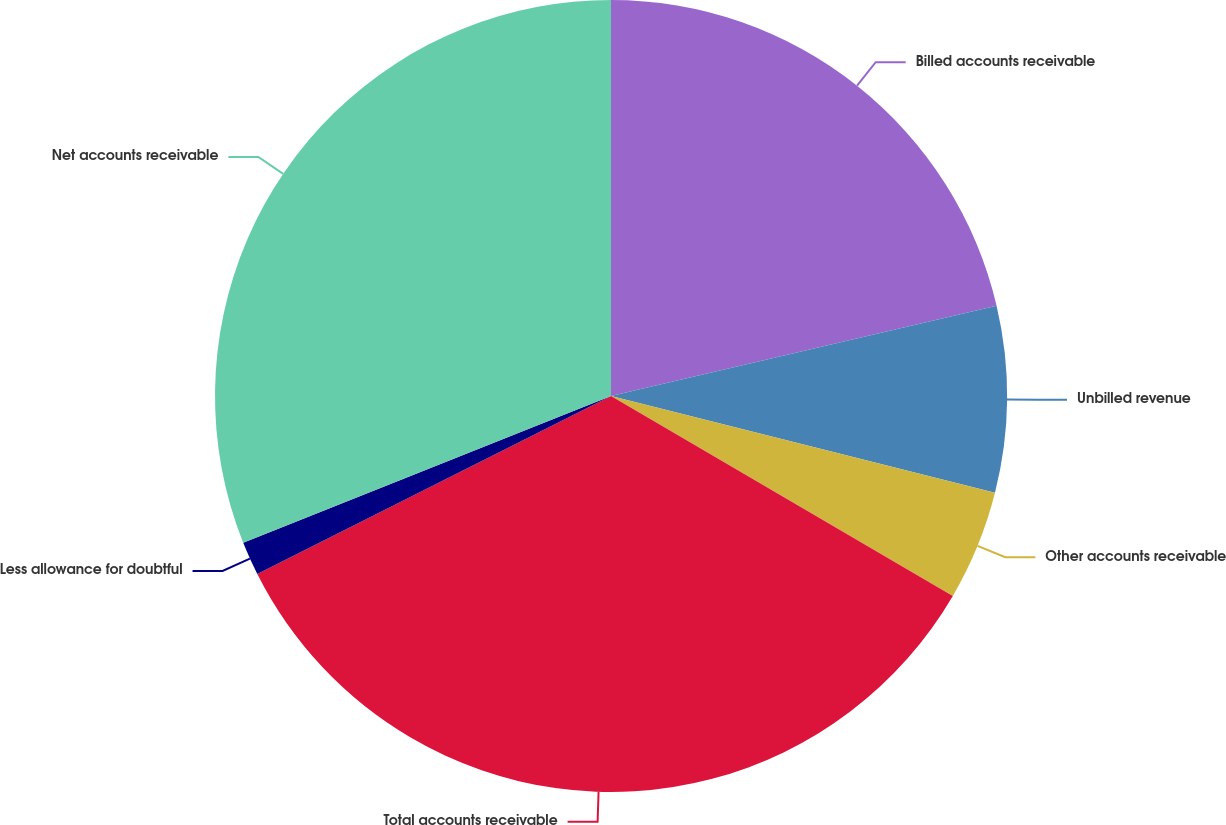Convert chart to OTSL. <chart><loc_0><loc_0><loc_500><loc_500><pie_chart><fcel>Billed accounts receivable<fcel>Unbilled revenue<fcel>Other accounts receivable<fcel>Total accounts receivable<fcel>Less allowance for doubtful<fcel>Net accounts receivable<nl><fcel>21.34%<fcel>7.59%<fcel>4.49%<fcel>34.15%<fcel>1.38%<fcel>31.04%<nl></chart> 